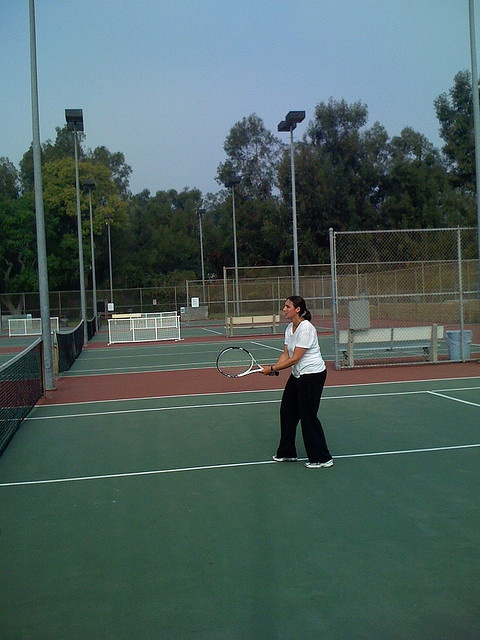Describe the objects in this image and their specific colors. I can see people in gray, black, lightgray, brown, and darkgray tones, bench in gray and darkgray tones, tennis racket in gray, darkgray, brown, and black tones, bench in gray and tan tones, and bench in gray, beige, black, and tan tones in this image. 